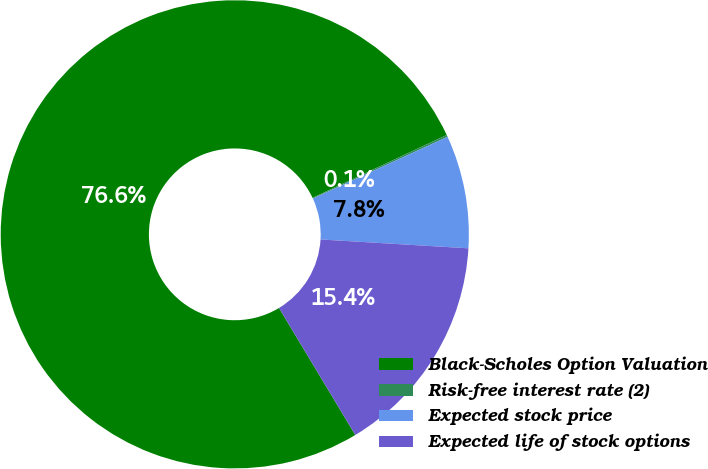<chart> <loc_0><loc_0><loc_500><loc_500><pie_chart><fcel>Black-Scholes Option Valuation<fcel>Risk-free interest rate (2)<fcel>Expected stock price<fcel>Expected life of stock options<nl><fcel>76.63%<fcel>0.14%<fcel>7.79%<fcel>15.44%<nl></chart> 